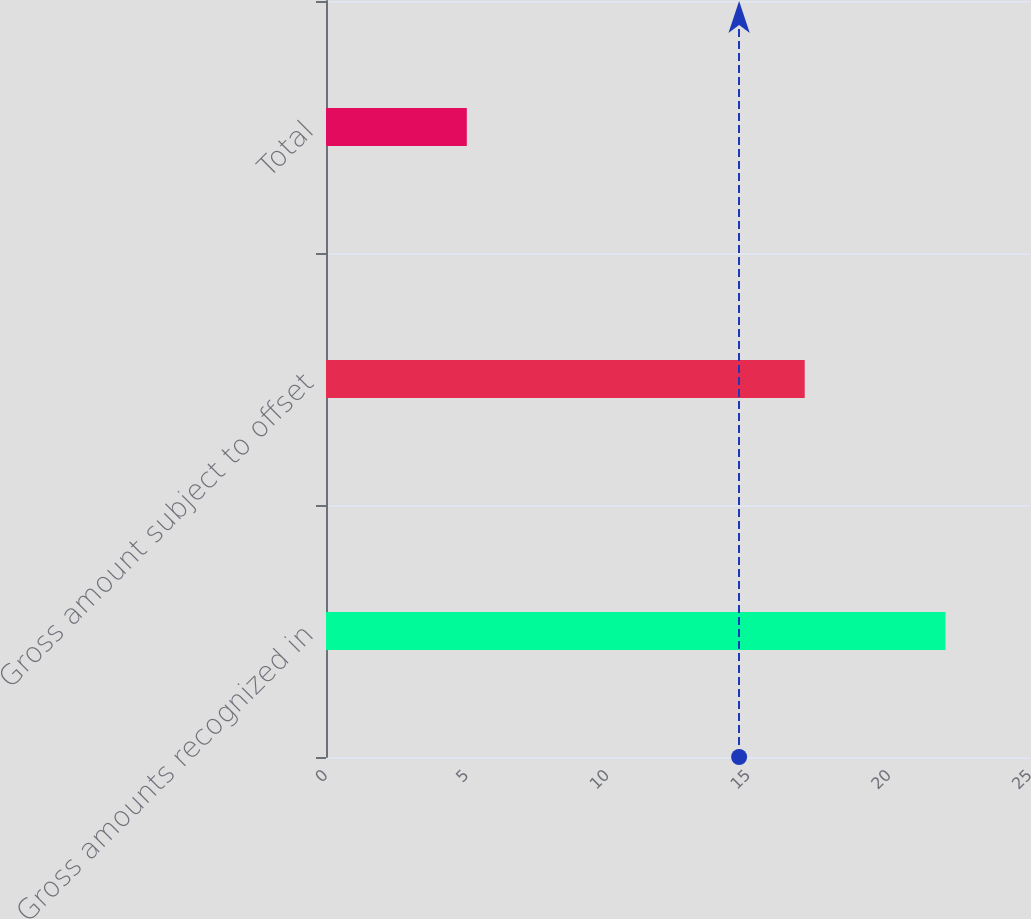<chart> <loc_0><loc_0><loc_500><loc_500><bar_chart><fcel>Gross amounts recognized in<fcel>Gross amount subject to offset<fcel>Total<nl><fcel>22<fcel>17<fcel>5<nl></chart> 